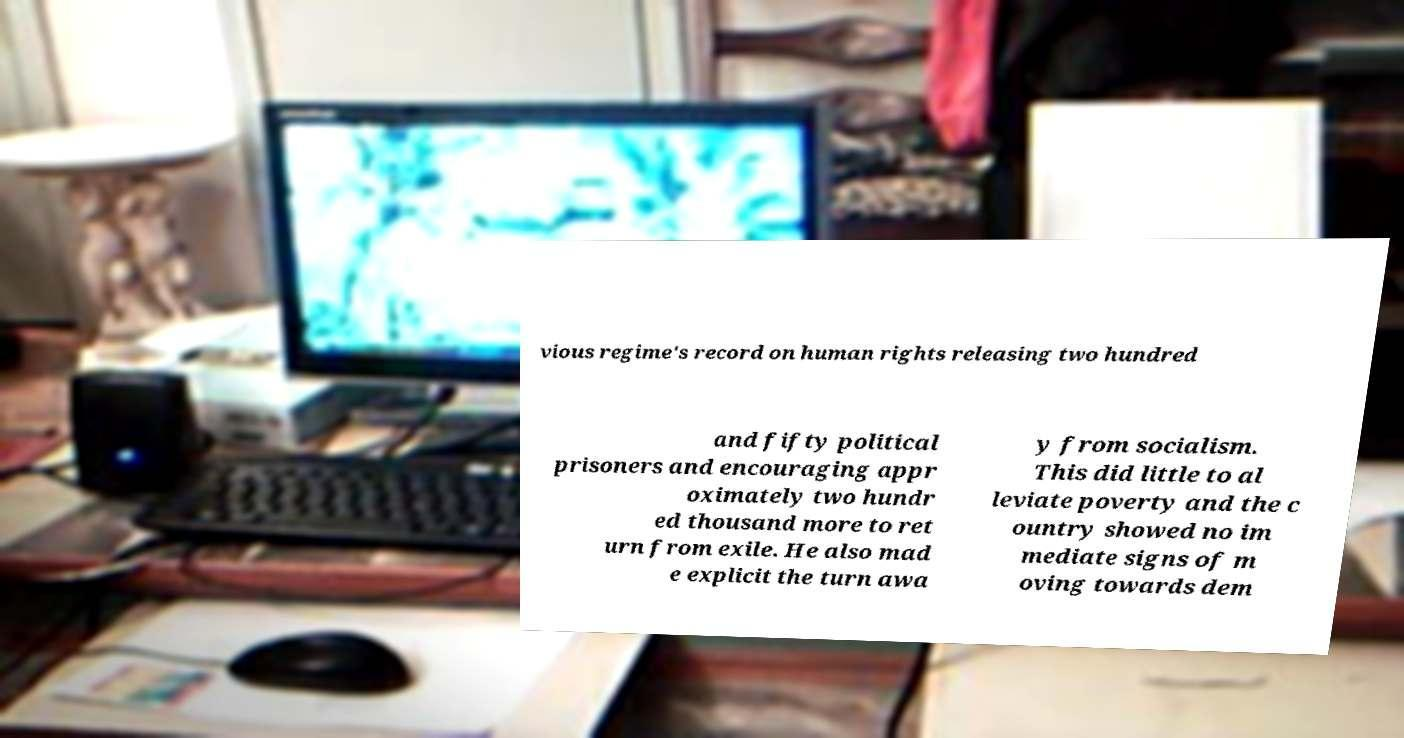Please read and relay the text visible in this image. What does it say? vious regime's record on human rights releasing two hundred and fifty political prisoners and encouraging appr oximately two hundr ed thousand more to ret urn from exile. He also mad e explicit the turn awa y from socialism. This did little to al leviate poverty and the c ountry showed no im mediate signs of m oving towards dem 